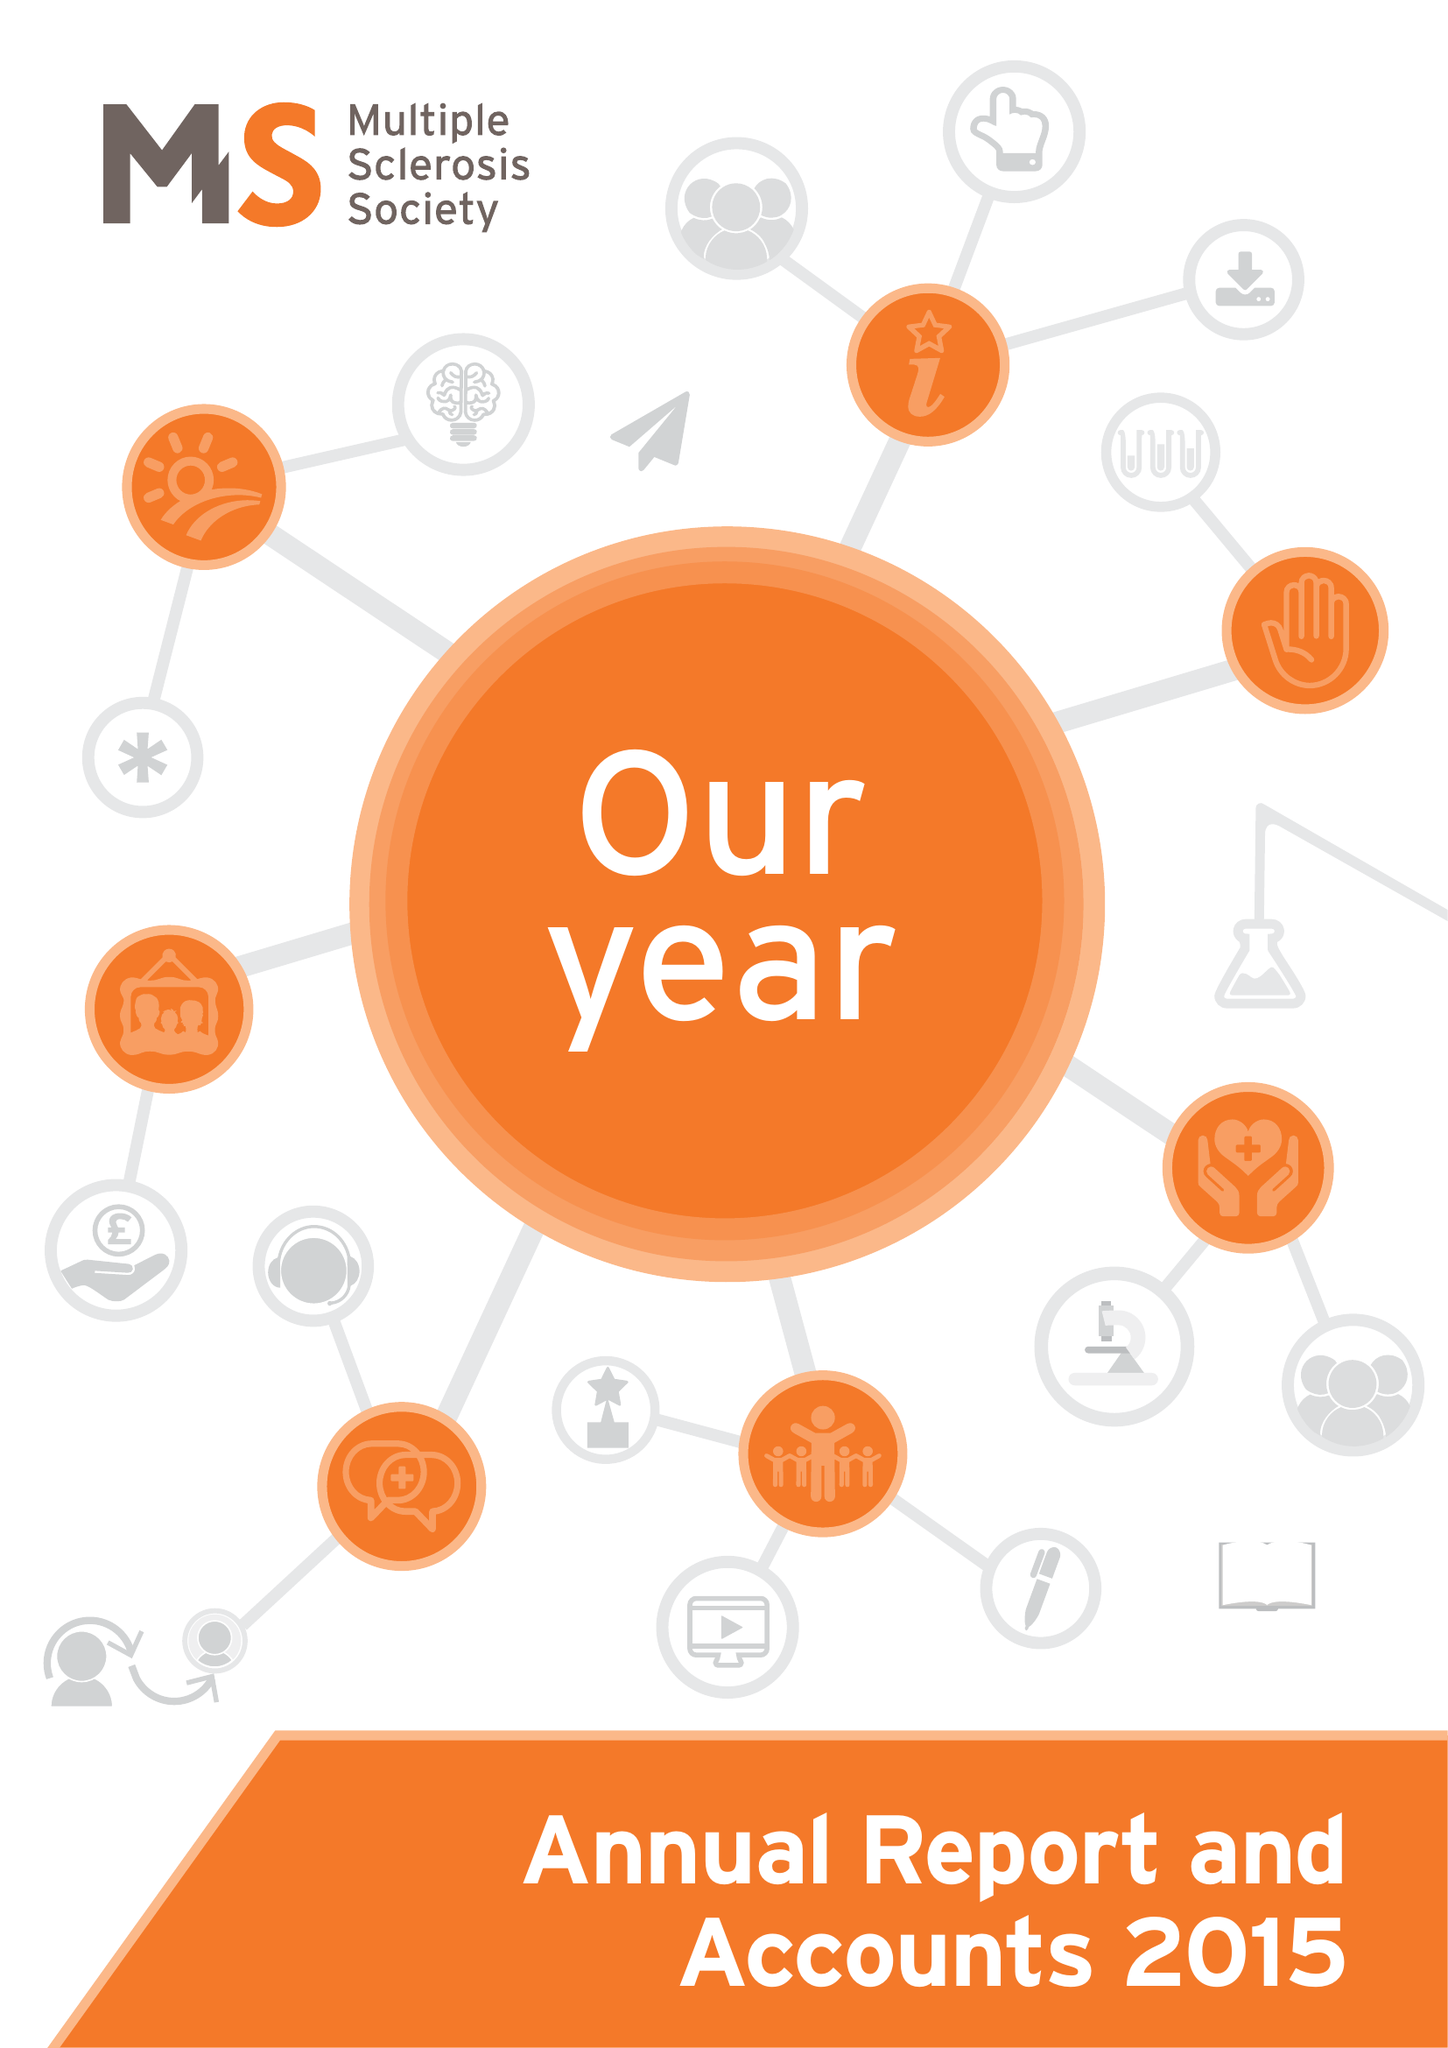What is the value for the report_date?
Answer the question using a single word or phrase. 2015-12-31 